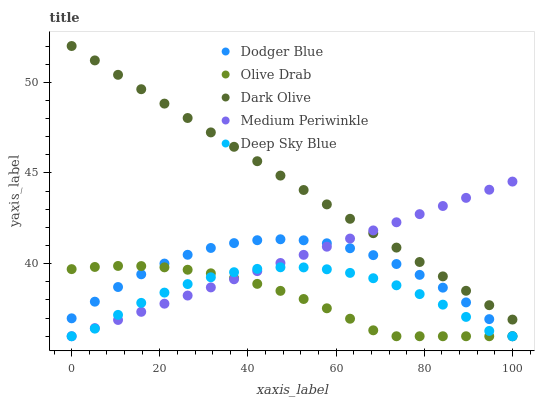Does Olive Drab have the minimum area under the curve?
Answer yes or no. Yes. Does Dark Olive have the maximum area under the curve?
Answer yes or no. Yes. Does Dodger Blue have the minimum area under the curve?
Answer yes or no. No. Does Dodger Blue have the maximum area under the curve?
Answer yes or no. No. Is Medium Periwinkle the smoothest?
Answer yes or no. Yes. Is Deep Sky Blue the roughest?
Answer yes or no. Yes. Is Dark Olive the smoothest?
Answer yes or no. No. Is Dark Olive the roughest?
Answer yes or no. No. Does Medium Periwinkle have the lowest value?
Answer yes or no. Yes. Does Dark Olive have the lowest value?
Answer yes or no. No. Does Dark Olive have the highest value?
Answer yes or no. Yes. Does Dodger Blue have the highest value?
Answer yes or no. No. Is Deep Sky Blue less than Dark Olive?
Answer yes or no. Yes. Is Dark Olive greater than Olive Drab?
Answer yes or no. Yes. Does Deep Sky Blue intersect Olive Drab?
Answer yes or no. Yes. Is Deep Sky Blue less than Olive Drab?
Answer yes or no. No. Is Deep Sky Blue greater than Olive Drab?
Answer yes or no. No. Does Deep Sky Blue intersect Dark Olive?
Answer yes or no. No. 